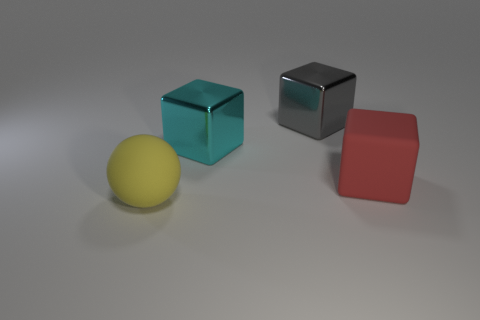What number of other rubber blocks are the same size as the cyan cube?
Keep it short and to the point. 1. The object that is behind the large metallic block in front of the gray metal cube is what shape?
Your response must be concise. Cube. Is the number of large gray metal objects less than the number of small gray shiny cubes?
Ensure brevity in your answer.  No. What is the color of the matte thing right of the sphere?
Ensure brevity in your answer.  Red. There is a object that is in front of the cyan object and behind the large yellow object; what is its material?
Provide a succinct answer. Rubber. What is the shape of the large yellow thing that is made of the same material as the large red block?
Your response must be concise. Sphere. There is a matte object that is to the left of the large red matte cube; what number of big yellow objects are right of it?
Ensure brevity in your answer.  0. What number of large blocks are both behind the rubber block and in front of the gray block?
Your answer should be compact. 1. The big rubber thing that is in front of the big block that is in front of the big cyan block is what color?
Provide a succinct answer. Yellow. Is the color of the matte thing on the right side of the large cyan object the same as the matte sphere?
Ensure brevity in your answer.  No. 